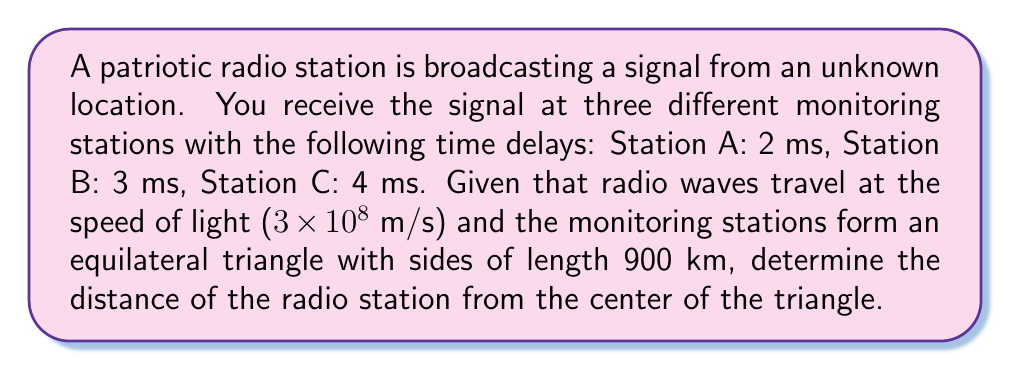What is the answer to this math problem? Let's approach this step-by-step:

1) First, we need to convert the time delays to distances. We can do this using the formula:
   $$d = c \times t$$
   where $d$ is distance, $c$ is the speed of light, and $t$ is time.

2) For Station A: $d_A = 3 \times 10^8 \times 0.002 = 600,000$ m = 600 km
   For Station B: $d_B = 3 \times 10^8 \times 0.003 = 900,000$ m = 900 km
   For Station C: $d_C = 3 \times 10^8 \times 0.004 = 1,200,000$ m = 1200 km

3) Let's denote the distance from the center of the triangle to the radio station as $x$.

4) The distance from the center of an equilateral triangle to any of its vertices is:
   $$\frac{\sqrt{3}}{3} \times \text{side length} = \frac{\sqrt{3}}{3} \times 900 = 300\sqrt{3}$$ km

5) Now, we can set up three equations based on the Pythagorean theorem:
   $$(300\sqrt{3})^2 + x^2 = 600^2$$
   $$(300\sqrt{3})^2 + x^2 = 900^2$$
   $$(300\sqrt{3})^2 + x^2 = 1200^2$$

6) We only need one of these equations. Let's use the first one:
   $$270,000 + x^2 = 360,000$$

7) Solving for $x$:
   $$x^2 = 90,000$$
   $$x = 300\sqrt{10}$$ km

Therefore, the distance of the radio station from the center of the triangle is $300\sqrt{10}$ km.
Answer: $300\sqrt{10}$ km 